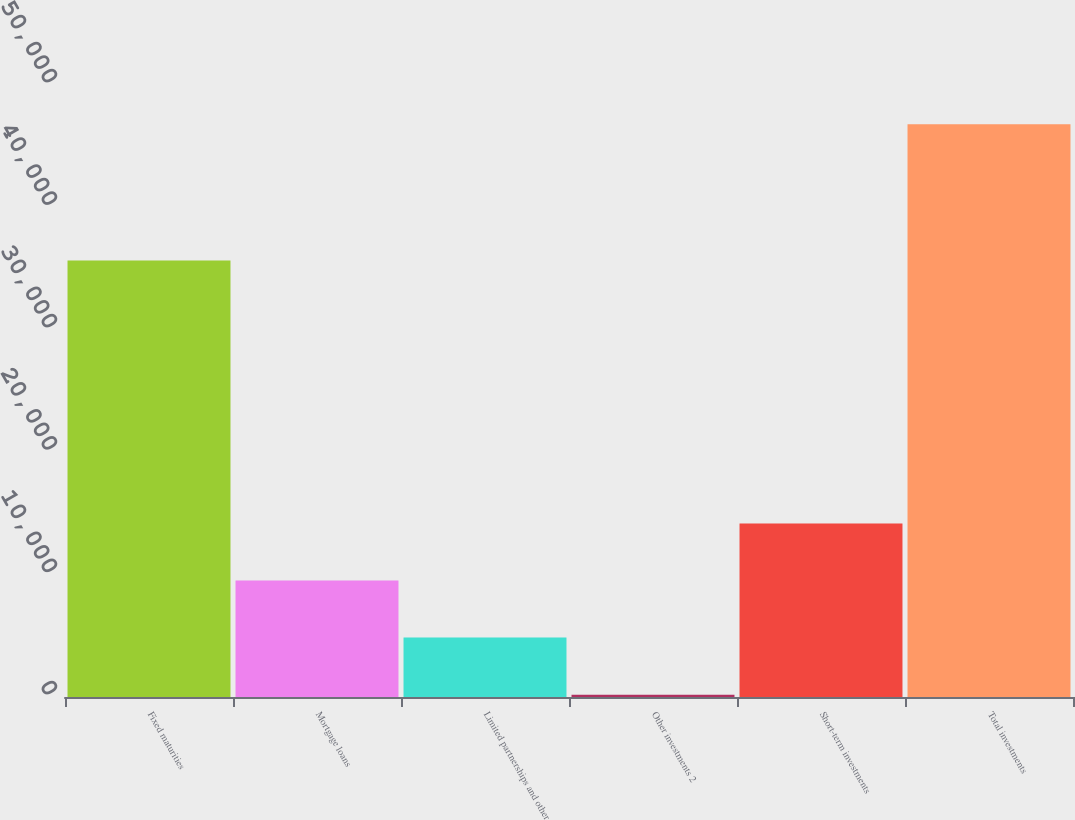Convert chart. <chart><loc_0><loc_0><loc_500><loc_500><bar_chart><fcel>Fixed maturities<fcel>Mortgage loans<fcel>Limited partnerships and other<fcel>Other investments 2<fcel>Short-term investments<fcel>Total investments<nl><fcel>35652<fcel>9511.6<fcel>4851.8<fcel>192<fcel>14171.4<fcel>46790<nl></chart> 